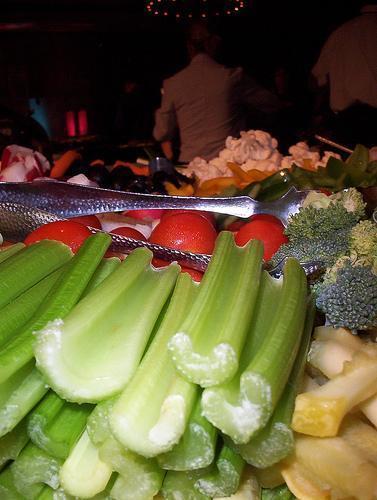How many tomatoes are there?
Give a very brief answer. 6. 